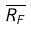<formula> <loc_0><loc_0><loc_500><loc_500>\overline { R _ { F } }</formula> 